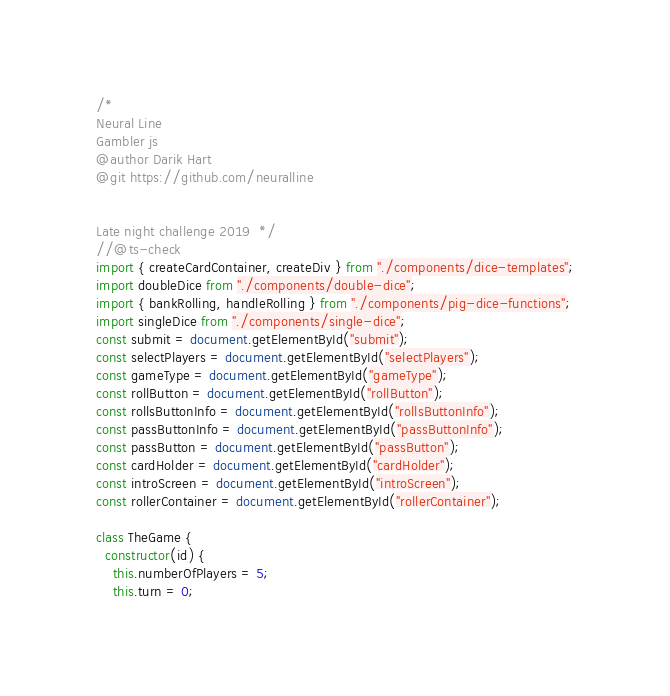Convert code to text. <code><loc_0><loc_0><loc_500><loc_500><_JavaScript_>/* 
Neural Line
Gambler js
@author Darik Hart
@git https://github.com/neuralline


Late night challenge 2019  */
//@ts-check
import { createCardContainer, createDiv } from "./components/dice-templates";
import doubleDice from "./components/double-dice";
import { bankRolling, handleRolling } from "./components/pig-dice-functions";
import singleDice from "./components/single-dice";
const submit = document.getElementById("submit");
const selectPlayers = document.getElementById("selectPlayers");
const gameType = document.getElementById("gameType");
const rollButton = document.getElementById("rollButton");
const rollsButtonInfo = document.getElementById("rollsButtonInfo");
const passButtonInfo = document.getElementById("passButtonInfo");
const passButton = document.getElementById("passButton");
const cardHolder = document.getElementById("cardHolder");
const introScreen = document.getElementById("introScreen");
const rollerContainer = document.getElementById("rollerContainer");

class TheGame {
  constructor(id) {
    this.numberOfPlayers = 5;
    this.turn = 0;</code> 